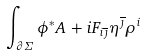Convert formula to latex. <formula><loc_0><loc_0><loc_500><loc_500>\int _ { \partial \Sigma } \phi ^ { * } A \, + \, i F _ { i \overline { \jmath } } \eta ^ { \overline { \jmath } } \rho ^ { i }</formula> 